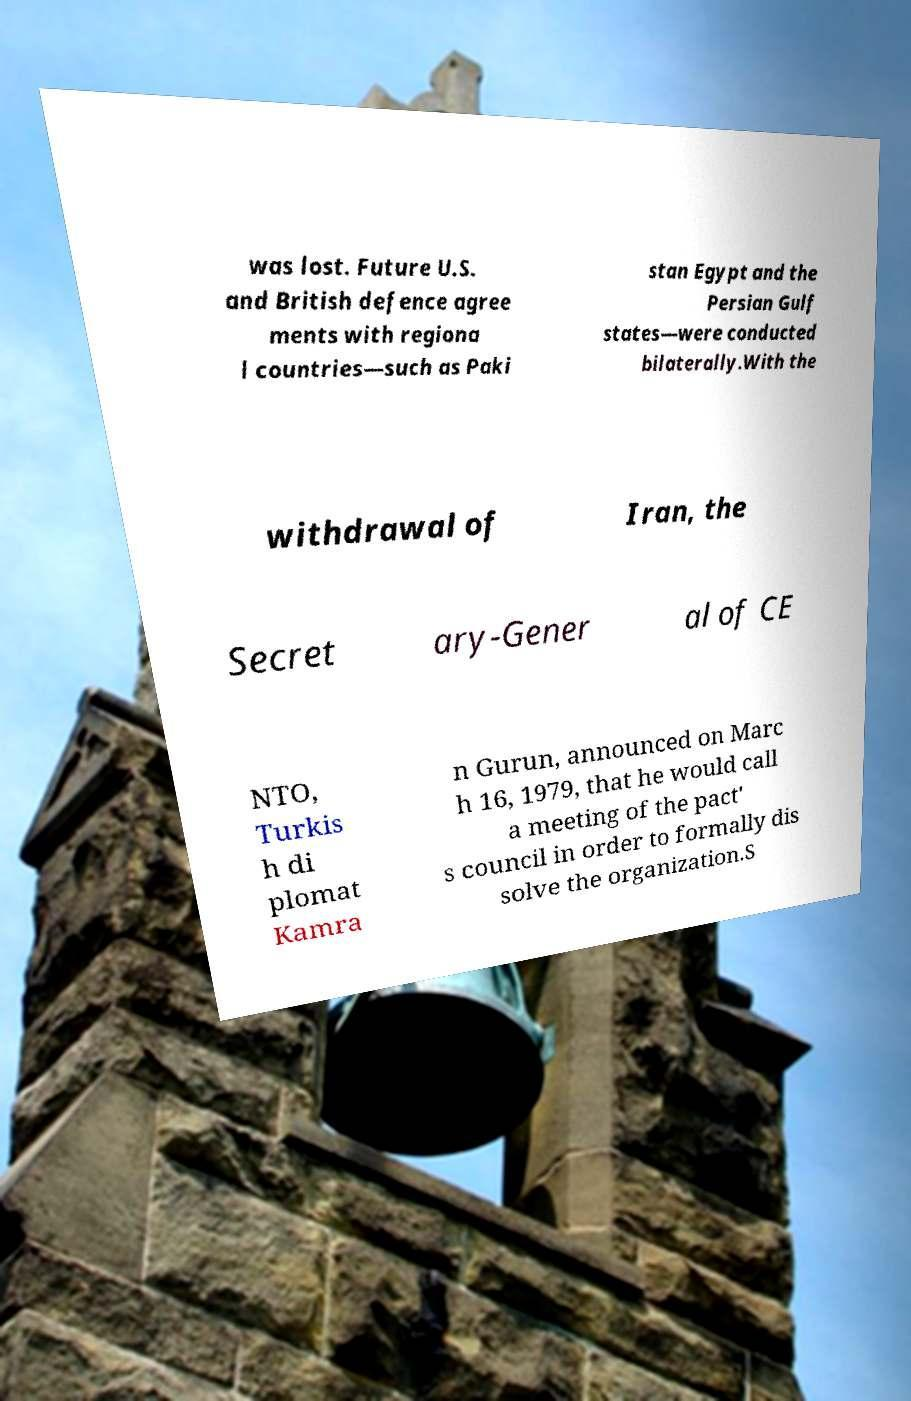What messages or text are displayed in this image? I need them in a readable, typed format. was lost. Future U.S. and British defence agree ments with regiona l countries—such as Paki stan Egypt and the Persian Gulf states—were conducted bilaterally.With the withdrawal of Iran, the Secret ary-Gener al of CE NTO, Turkis h di plomat Kamra n Gurun, announced on Marc h 16, 1979, that he would call a meeting of the pact' s council in order to formally dis solve the organization.S 